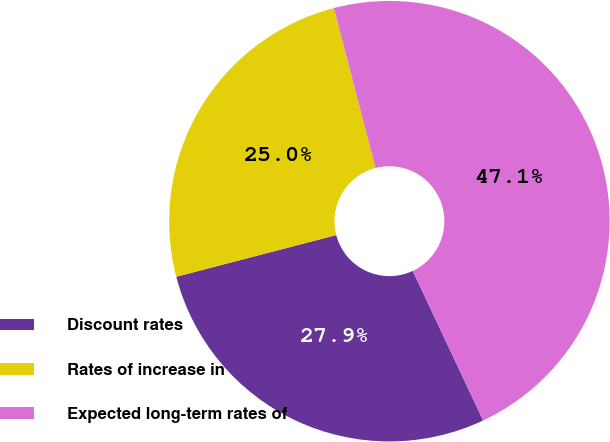Convert chart. <chart><loc_0><loc_0><loc_500><loc_500><pie_chart><fcel>Discount rates<fcel>Rates of increase in<fcel>Expected long-term rates of<nl><fcel>27.94%<fcel>25.0%<fcel>47.06%<nl></chart> 